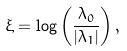Convert formula to latex. <formula><loc_0><loc_0><loc_500><loc_500>\xi = \log \left ( \frac { \lambda _ { 0 } } { | \lambda _ { 1 } | } \right ) ,</formula> 